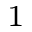Convert formula to latex. <formula><loc_0><loc_0><loc_500><loc_500>^ { 1 }</formula> 